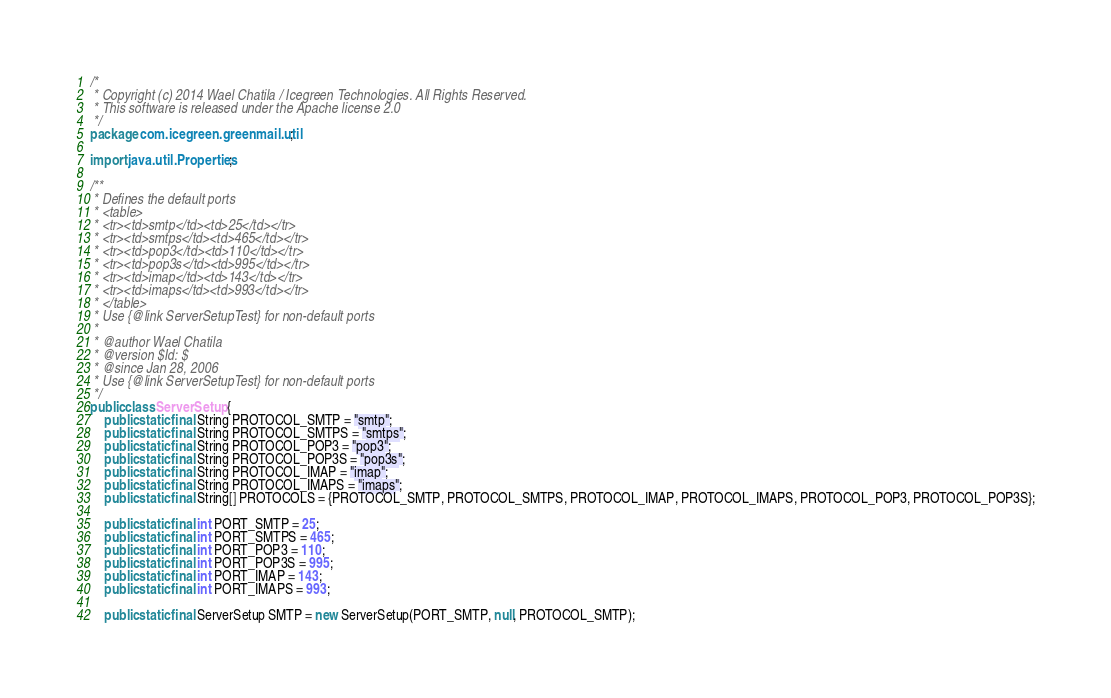<code> <loc_0><loc_0><loc_500><loc_500><_Java_>/*
 * Copyright (c) 2014 Wael Chatila / Icegreen Technologies. All Rights Reserved.
 * This software is released under the Apache license 2.0
 */
package com.icegreen.greenmail.util;

import java.util.Properties;

/**
 * Defines the default ports
 * <table>
 * <tr><td>smtp</td><td>25</td></tr>
 * <tr><td>smtps</td><td>465</td></tr>
 * <tr><td>pop3</td><td>110</td></tr>
 * <tr><td>pop3s</td><td>995</td></tr>
 * <tr><td>imap</td><td>143</td></tr>
 * <tr><td>imaps</td><td>993</td></tr>
 * </table>
 * Use {@link ServerSetupTest} for non-default ports
 *
 * @author Wael Chatila
 * @version $Id: $
 * @since Jan 28, 2006
 * Use {@link ServerSetupTest} for non-default ports
 */
public class ServerSetup {
    public static final String PROTOCOL_SMTP = "smtp";
    public static final String PROTOCOL_SMTPS = "smtps";
    public static final String PROTOCOL_POP3 = "pop3";
    public static final String PROTOCOL_POP3S = "pop3s";
    public static final String PROTOCOL_IMAP = "imap";
    public static final String PROTOCOL_IMAPS = "imaps";
    public static final String[] PROTOCOLS = {PROTOCOL_SMTP, PROTOCOL_SMTPS, PROTOCOL_IMAP, PROTOCOL_IMAPS, PROTOCOL_POP3, PROTOCOL_POP3S};

    public static final int PORT_SMTP = 25;
    public static final int PORT_SMTPS = 465;
    public static final int PORT_POP3 = 110;
    public static final int PORT_POP3S = 995;
    public static final int PORT_IMAP = 143;
    public static final int PORT_IMAPS = 993;

    public static final ServerSetup SMTP = new ServerSetup(PORT_SMTP, null, PROTOCOL_SMTP);</code> 